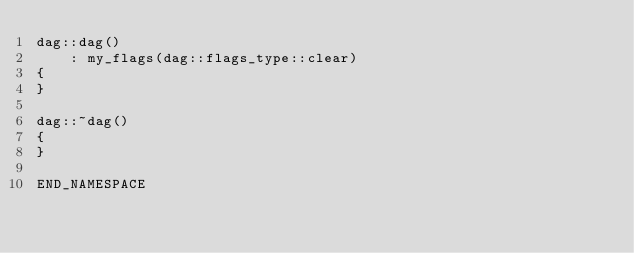Convert code to text. <code><loc_0><loc_0><loc_500><loc_500><_C++_>dag::dag()
    : my_flags(dag::flags_type::clear)
{
}

dag::~dag()
{
}

END_NAMESPACE
</code> 